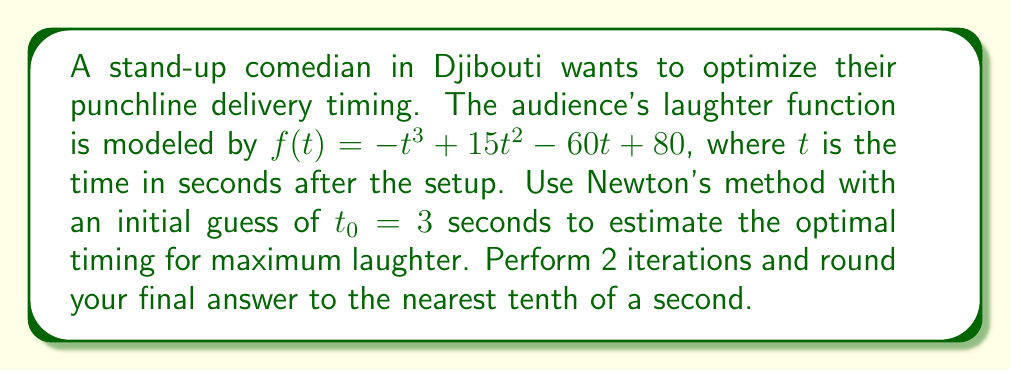Teach me how to tackle this problem. To find the optimal timing for maximum laughter, we need to find the maximum of the function $f(t) = -t^3 + 15t^2 - 60t + 80$. This occurs where the derivative $f'(t) = 0$.

Step 1: Calculate the derivative of $f(t)$:
$f'(t) = -3t^2 + 30t - 60$

Step 2: Set up Newton's method formula:
$$t_{n+1} = t_n - \frac{f'(t_n)}{f''(t_n)}$$

Step 3: Calculate the second derivative:
$f''(t) = -6t + 30$

Step 4: Perform the first iteration:
$t_1 = 3 - \frac{f'(3)}{f''(3)}$
$f'(3) = -3(3)^2 + 30(3) - 60 = -27 + 90 - 60 = 3$
$f''(3) = -6(3) + 30 = -18 + 30 = 12$
$t_1 = 3 - \frac{3}{12} = 3 - 0.25 = 2.75$

Step 5: Perform the second iteration:
$t_2 = 2.75 - \frac{f'(2.75)}{f''(2.75)}$
$f'(2.75) = -3(2.75)^2 + 30(2.75) - 60 = -22.6875 + 82.5 - 60 = -0.1875$
$f''(2.75) = -6(2.75) + 30 = -16.5 + 30 = 13.5$
$t_2 = 2.75 - \frac{-0.1875}{13.5} = 2.75 + 0.0139 = 2.7639$

Step 6: Round to the nearest tenth:
$2.7639 \approx 2.8$
Answer: 2.8 seconds 